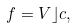<formula> <loc_0><loc_0><loc_500><loc_500>f = V \rfloor c ,</formula> 